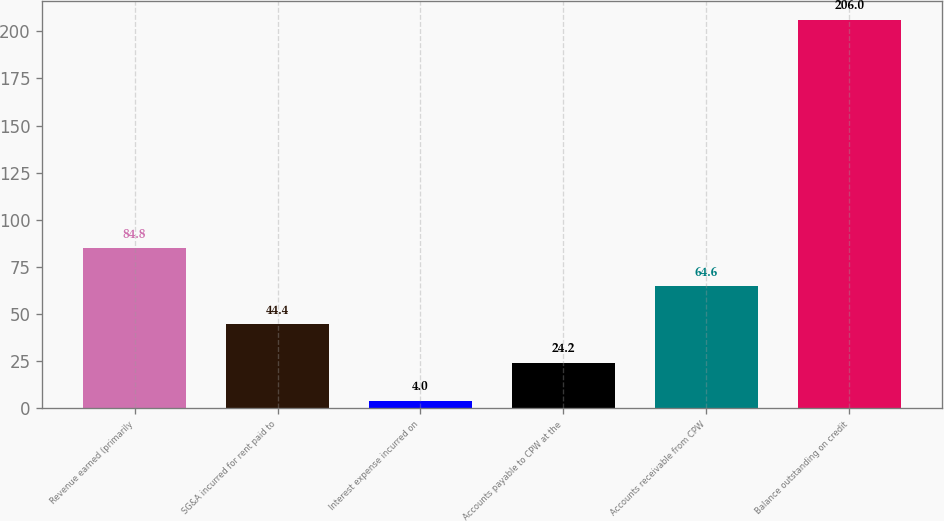Convert chart to OTSL. <chart><loc_0><loc_0><loc_500><loc_500><bar_chart><fcel>Revenue earned (primarily<fcel>SG&A incurred for rent paid to<fcel>Interest expense incurred on<fcel>Accounts payable to CPW at the<fcel>Accounts receivable from CPW<fcel>Balance outstanding on credit<nl><fcel>84.8<fcel>44.4<fcel>4<fcel>24.2<fcel>64.6<fcel>206<nl></chart> 